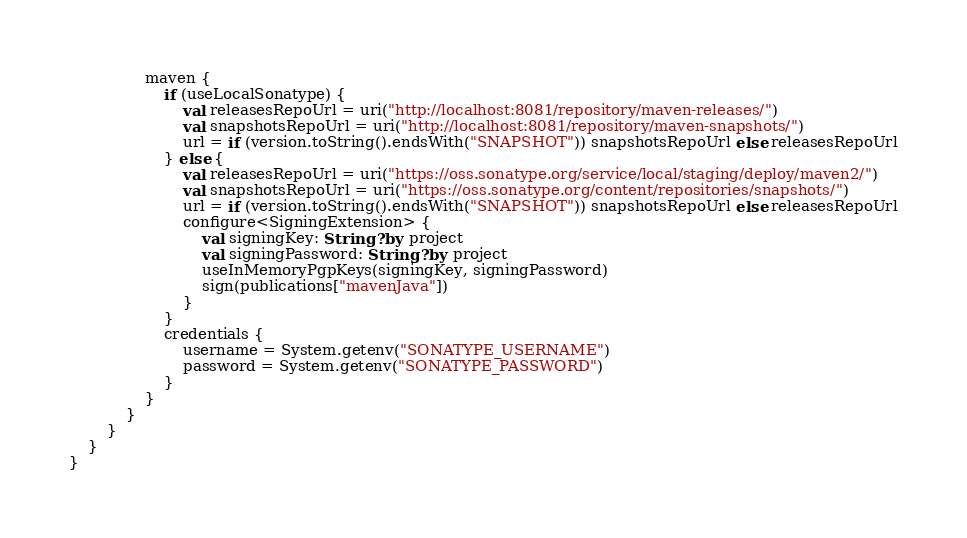<code> <loc_0><loc_0><loc_500><loc_500><_Kotlin_>                maven {
                    if (useLocalSonatype) {
                        val releasesRepoUrl = uri("http://localhost:8081/repository/maven-releases/")
                        val snapshotsRepoUrl = uri("http://localhost:8081/repository/maven-snapshots/")
                        url = if (version.toString().endsWith("SNAPSHOT")) snapshotsRepoUrl else releasesRepoUrl
                    } else {
                        val releasesRepoUrl = uri("https://oss.sonatype.org/service/local/staging/deploy/maven2/")
                        val snapshotsRepoUrl = uri("https://oss.sonatype.org/content/repositories/snapshots/")
                        url = if (version.toString().endsWith("SNAPSHOT")) snapshotsRepoUrl else releasesRepoUrl
                        configure<SigningExtension> {
                            val signingKey: String? by project
                            val signingPassword: String? by project
                            useInMemoryPgpKeys(signingKey, signingPassword)
                            sign(publications["mavenJava"])
                        }
                    }
                    credentials {
                        username = System.getenv("SONATYPE_USERNAME")
                        password = System.getenv("SONATYPE_PASSWORD")
                    }
                }
            }
        }
    }
}
</code> 